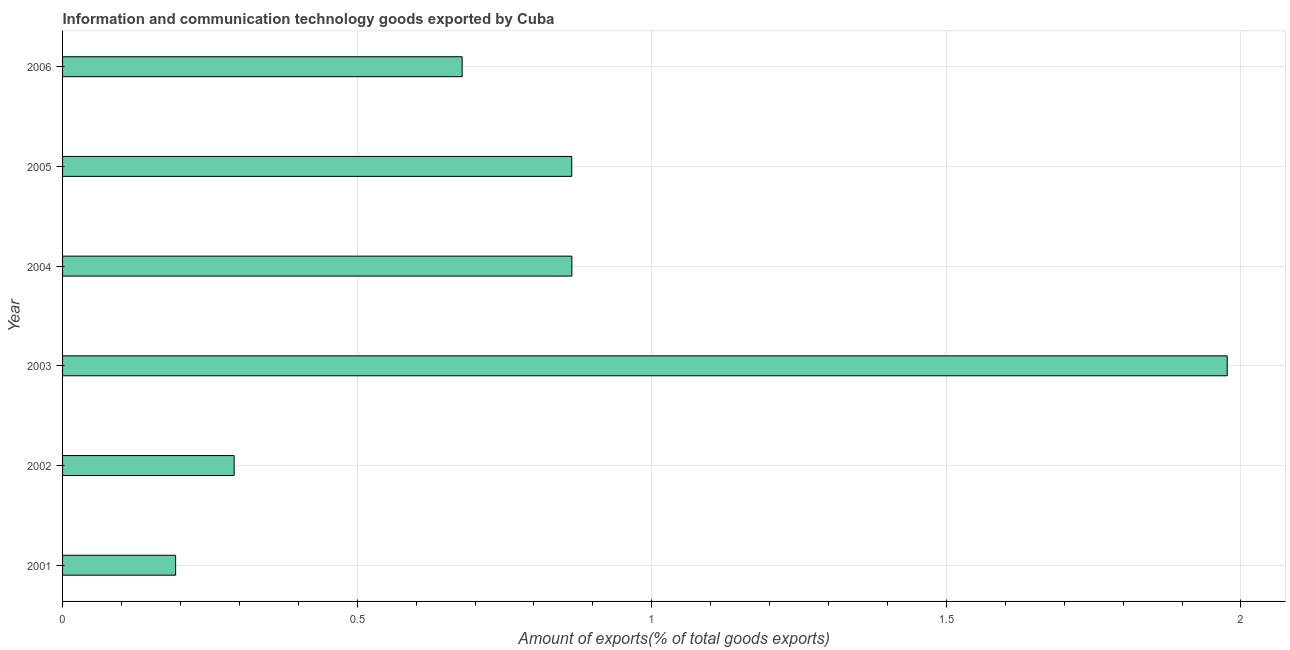Does the graph contain any zero values?
Your response must be concise. No. What is the title of the graph?
Give a very brief answer. Information and communication technology goods exported by Cuba. What is the label or title of the X-axis?
Provide a succinct answer. Amount of exports(% of total goods exports). What is the amount of ict goods exports in 2002?
Make the answer very short. 0.29. Across all years, what is the maximum amount of ict goods exports?
Provide a succinct answer. 1.98. Across all years, what is the minimum amount of ict goods exports?
Provide a short and direct response. 0.19. What is the sum of the amount of ict goods exports?
Your answer should be compact. 4.87. What is the difference between the amount of ict goods exports in 2002 and 2006?
Give a very brief answer. -0.39. What is the average amount of ict goods exports per year?
Your response must be concise. 0.81. What is the median amount of ict goods exports?
Ensure brevity in your answer.  0.77. In how many years, is the amount of ict goods exports greater than 1.6 %?
Give a very brief answer. 1. What is the ratio of the amount of ict goods exports in 2005 to that in 2006?
Offer a terse response. 1.27. Is the amount of ict goods exports in 2001 less than that in 2006?
Keep it short and to the point. Yes. Is the difference between the amount of ict goods exports in 2001 and 2006 greater than the difference between any two years?
Offer a very short reply. No. What is the difference between the highest and the second highest amount of ict goods exports?
Keep it short and to the point. 1.11. What is the difference between the highest and the lowest amount of ict goods exports?
Your response must be concise. 1.78. In how many years, is the amount of ict goods exports greater than the average amount of ict goods exports taken over all years?
Your answer should be compact. 3. Are all the bars in the graph horizontal?
Keep it short and to the point. Yes. How many years are there in the graph?
Make the answer very short. 6. Are the values on the major ticks of X-axis written in scientific E-notation?
Make the answer very short. No. What is the Amount of exports(% of total goods exports) in 2001?
Offer a very short reply. 0.19. What is the Amount of exports(% of total goods exports) in 2002?
Give a very brief answer. 0.29. What is the Amount of exports(% of total goods exports) in 2003?
Your response must be concise. 1.98. What is the Amount of exports(% of total goods exports) of 2004?
Provide a short and direct response. 0.86. What is the Amount of exports(% of total goods exports) in 2005?
Make the answer very short. 0.86. What is the Amount of exports(% of total goods exports) of 2006?
Give a very brief answer. 0.68. What is the difference between the Amount of exports(% of total goods exports) in 2001 and 2002?
Keep it short and to the point. -0.1. What is the difference between the Amount of exports(% of total goods exports) in 2001 and 2003?
Offer a very short reply. -1.78. What is the difference between the Amount of exports(% of total goods exports) in 2001 and 2004?
Provide a succinct answer. -0.67. What is the difference between the Amount of exports(% of total goods exports) in 2001 and 2005?
Give a very brief answer. -0.67. What is the difference between the Amount of exports(% of total goods exports) in 2001 and 2006?
Ensure brevity in your answer.  -0.49. What is the difference between the Amount of exports(% of total goods exports) in 2002 and 2003?
Provide a succinct answer. -1.69. What is the difference between the Amount of exports(% of total goods exports) in 2002 and 2004?
Your response must be concise. -0.57. What is the difference between the Amount of exports(% of total goods exports) in 2002 and 2005?
Your answer should be very brief. -0.57. What is the difference between the Amount of exports(% of total goods exports) in 2002 and 2006?
Your answer should be compact. -0.39. What is the difference between the Amount of exports(% of total goods exports) in 2003 and 2004?
Your response must be concise. 1.11. What is the difference between the Amount of exports(% of total goods exports) in 2003 and 2005?
Keep it short and to the point. 1.11. What is the difference between the Amount of exports(% of total goods exports) in 2003 and 2006?
Ensure brevity in your answer.  1.3. What is the difference between the Amount of exports(% of total goods exports) in 2004 and 2005?
Your answer should be very brief. 0. What is the difference between the Amount of exports(% of total goods exports) in 2004 and 2006?
Your answer should be very brief. 0.19. What is the difference between the Amount of exports(% of total goods exports) in 2005 and 2006?
Make the answer very short. 0.19. What is the ratio of the Amount of exports(% of total goods exports) in 2001 to that in 2002?
Give a very brief answer. 0.66. What is the ratio of the Amount of exports(% of total goods exports) in 2001 to that in 2003?
Give a very brief answer. 0.1. What is the ratio of the Amount of exports(% of total goods exports) in 2001 to that in 2004?
Provide a succinct answer. 0.22. What is the ratio of the Amount of exports(% of total goods exports) in 2001 to that in 2005?
Provide a succinct answer. 0.22. What is the ratio of the Amount of exports(% of total goods exports) in 2001 to that in 2006?
Make the answer very short. 0.28. What is the ratio of the Amount of exports(% of total goods exports) in 2002 to that in 2003?
Your answer should be compact. 0.15. What is the ratio of the Amount of exports(% of total goods exports) in 2002 to that in 2004?
Your answer should be very brief. 0.34. What is the ratio of the Amount of exports(% of total goods exports) in 2002 to that in 2005?
Offer a terse response. 0.34. What is the ratio of the Amount of exports(% of total goods exports) in 2002 to that in 2006?
Provide a short and direct response. 0.43. What is the ratio of the Amount of exports(% of total goods exports) in 2003 to that in 2004?
Provide a short and direct response. 2.29. What is the ratio of the Amount of exports(% of total goods exports) in 2003 to that in 2005?
Keep it short and to the point. 2.29. What is the ratio of the Amount of exports(% of total goods exports) in 2003 to that in 2006?
Offer a very short reply. 2.92. What is the ratio of the Amount of exports(% of total goods exports) in 2004 to that in 2006?
Your answer should be very brief. 1.27. What is the ratio of the Amount of exports(% of total goods exports) in 2005 to that in 2006?
Offer a very short reply. 1.27. 